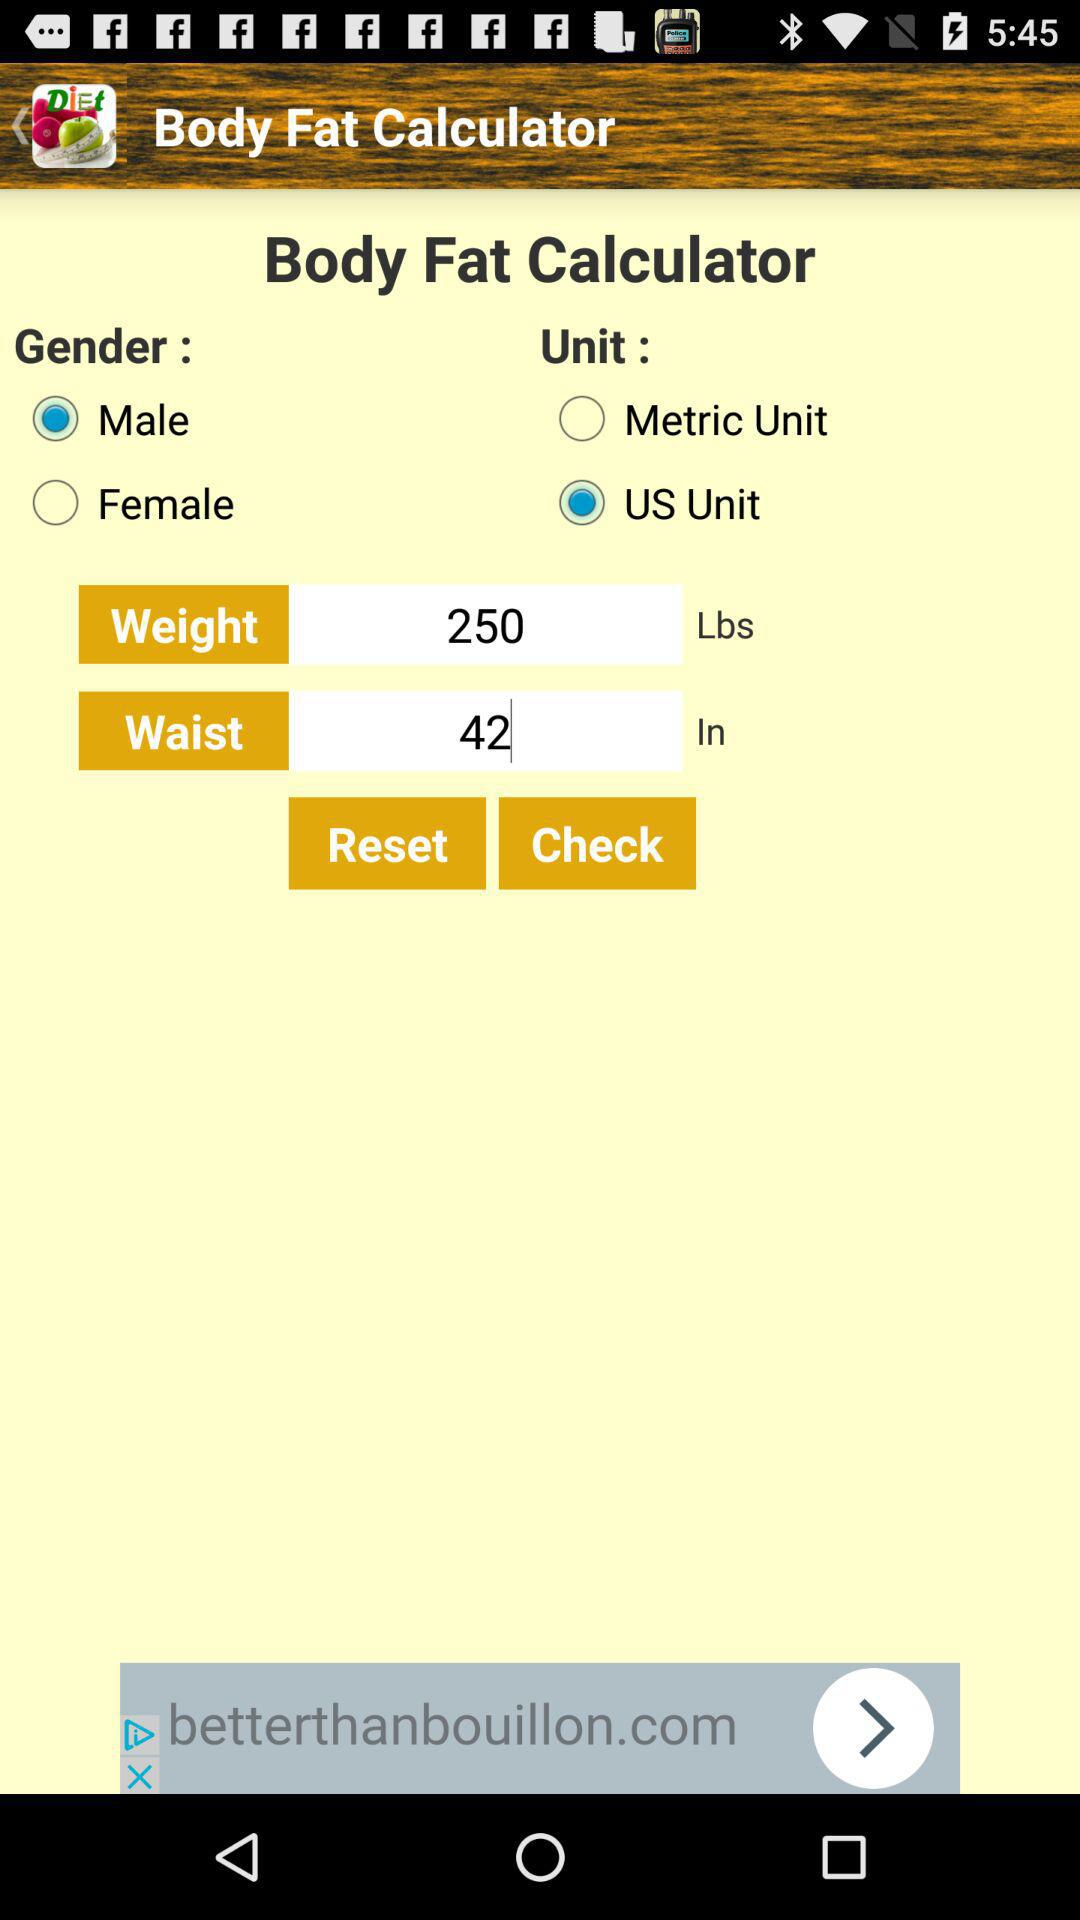How much weight is entered? The entered weight is 250 lbs. 